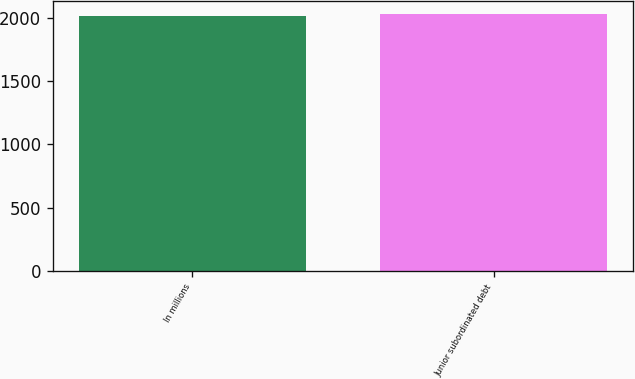Convert chart. <chart><loc_0><loc_0><loc_500><loc_500><bar_chart><fcel>In millions<fcel>Junior subordinated debt<nl><fcel>2016<fcel>2028<nl></chart> 